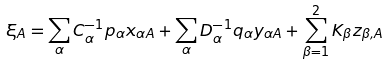<formula> <loc_0><loc_0><loc_500><loc_500>\xi _ { A } = \sum _ { \alpha } C ^ { - 1 } _ { \alpha } p _ { \alpha } x _ { \alpha A } + \sum _ { \alpha } D ^ { - 1 } _ { \alpha } q _ { \alpha } y _ { \alpha A } + \sum _ { \beta = 1 } ^ { 2 } K _ { \beta } z _ { \beta , A }</formula> 